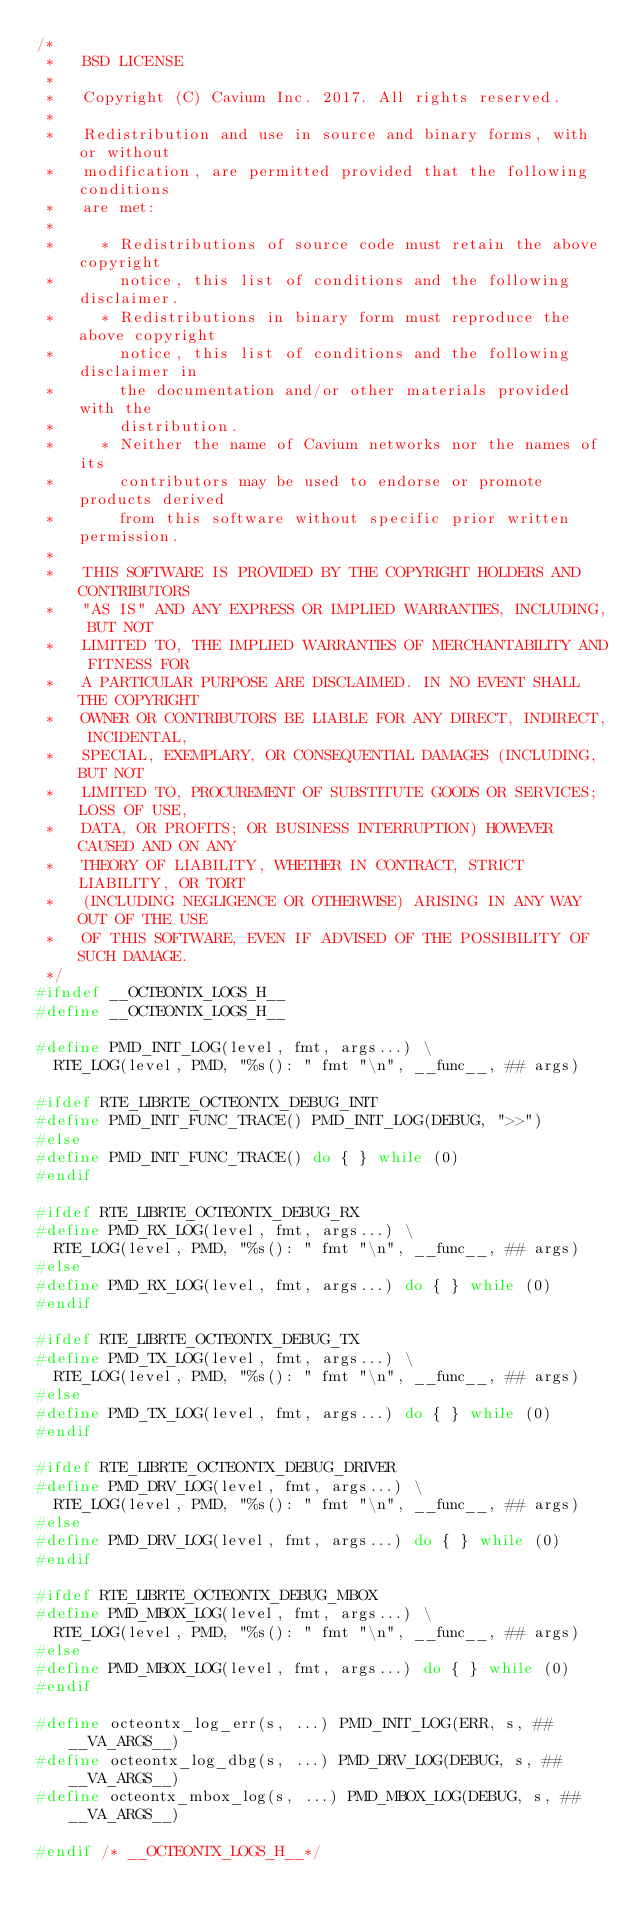Convert code to text. <code><loc_0><loc_0><loc_500><loc_500><_C_>/*
 *   BSD LICENSE
 *
 *   Copyright (C) Cavium Inc. 2017. All rights reserved.
 *
 *   Redistribution and use in source and binary forms, with or without
 *   modification, are permitted provided that the following conditions
 *   are met:
 *
 *     * Redistributions of source code must retain the above copyright
 *       notice, this list of conditions and the following disclaimer.
 *     * Redistributions in binary form must reproduce the above copyright
 *       notice, this list of conditions and the following disclaimer in
 *       the documentation and/or other materials provided with the
 *       distribution.
 *     * Neither the name of Cavium networks nor the names of its
 *       contributors may be used to endorse or promote products derived
 *       from this software without specific prior written permission.
 *
 *   THIS SOFTWARE IS PROVIDED BY THE COPYRIGHT HOLDERS AND CONTRIBUTORS
 *   "AS IS" AND ANY EXPRESS OR IMPLIED WARRANTIES, INCLUDING, BUT NOT
 *   LIMITED TO, THE IMPLIED WARRANTIES OF MERCHANTABILITY AND FITNESS FOR
 *   A PARTICULAR PURPOSE ARE DISCLAIMED. IN NO EVENT SHALL THE COPYRIGHT
 *   OWNER OR CONTRIBUTORS BE LIABLE FOR ANY DIRECT, INDIRECT, INCIDENTAL,
 *   SPECIAL, EXEMPLARY, OR CONSEQUENTIAL DAMAGES (INCLUDING, BUT NOT
 *   LIMITED TO, PROCUREMENT OF SUBSTITUTE GOODS OR SERVICES; LOSS OF USE,
 *   DATA, OR PROFITS; OR BUSINESS INTERRUPTION) HOWEVER CAUSED AND ON ANY
 *   THEORY OF LIABILITY, WHETHER IN CONTRACT, STRICT LIABILITY, OR TORT
 *   (INCLUDING NEGLIGENCE OR OTHERWISE) ARISING IN ANY WAY OUT OF THE USE
 *   OF THIS SOFTWARE, EVEN IF ADVISED OF THE POSSIBILITY OF SUCH DAMAGE.
 */
#ifndef __OCTEONTX_LOGS_H__
#define __OCTEONTX_LOGS_H__

#define PMD_INIT_LOG(level, fmt, args...) \
	RTE_LOG(level, PMD, "%s(): " fmt "\n", __func__, ## args)

#ifdef RTE_LIBRTE_OCTEONTX_DEBUG_INIT
#define PMD_INIT_FUNC_TRACE() PMD_INIT_LOG(DEBUG, ">>")
#else
#define PMD_INIT_FUNC_TRACE() do { } while (0)
#endif

#ifdef RTE_LIBRTE_OCTEONTX_DEBUG_RX
#define PMD_RX_LOG(level, fmt, args...) \
	RTE_LOG(level, PMD, "%s(): " fmt "\n", __func__, ## args)
#else
#define PMD_RX_LOG(level, fmt, args...) do { } while (0)
#endif

#ifdef RTE_LIBRTE_OCTEONTX_DEBUG_TX
#define PMD_TX_LOG(level, fmt, args...) \
	RTE_LOG(level, PMD, "%s(): " fmt "\n", __func__, ## args)
#else
#define PMD_TX_LOG(level, fmt, args...) do { } while (0)
#endif

#ifdef RTE_LIBRTE_OCTEONTX_DEBUG_DRIVER
#define PMD_DRV_LOG(level, fmt, args...) \
	RTE_LOG(level, PMD, "%s(): " fmt "\n", __func__, ## args)
#else
#define PMD_DRV_LOG(level, fmt, args...) do { } while (0)
#endif

#ifdef RTE_LIBRTE_OCTEONTX_DEBUG_MBOX
#define PMD_MBOX_LOG(level, fmt, args...) \
	RTE_LOG(level, PMD, "%s(): " fmt "\n", __func__, ## args)
#else
#define PMD_MBOX_LOG(level, fmt, args...) do { } while (0)
#endif

#define octeontx_log_err(s, ...) PMD_INIT_LOG(ERR, s, ##__VA_ARGS__)
#define octeontx_log_dbg(s, ...) PMD_DRV_LOG(DEBUG, s, ##__VA_ARGS__)
#define octeontx_mbox_log(s, ...) PMD_MBOX_LOG(DEBUG, s, ##__VA_ARGS__)

#endif /* __OCTEONTX_LOGS_H__*/
</code> 